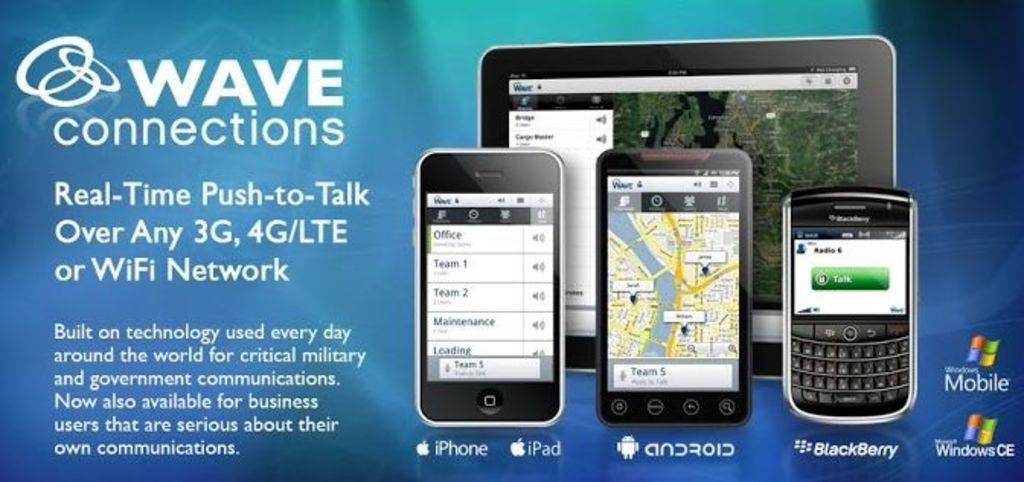<image>
Present a compact description of the photo's key features. An ad for Wave Connections shows iPhones and BlackBerries. 